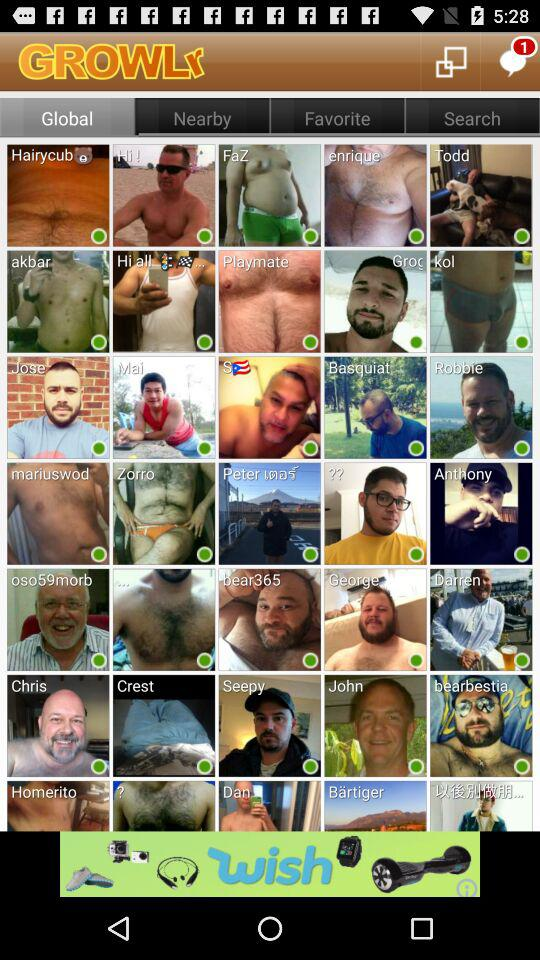How many messages were unread? There was 1 message unread. 